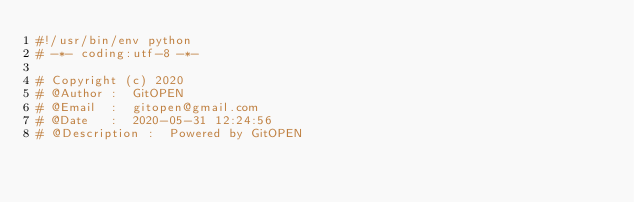Convert code to text. <code><loc_0><loc_0><loc_500><loc_500><_Python_>#!/usr/bin/env python
# -*- coding:utf-8 -*-

# Copyright (c) 2020
# @Author :  GitOPEN
# @Email  :  gitopen@gmail.com
# @Date   :  2020-05-31 12:24:56
# @Description :  Powered by GitOPEN
</code> 